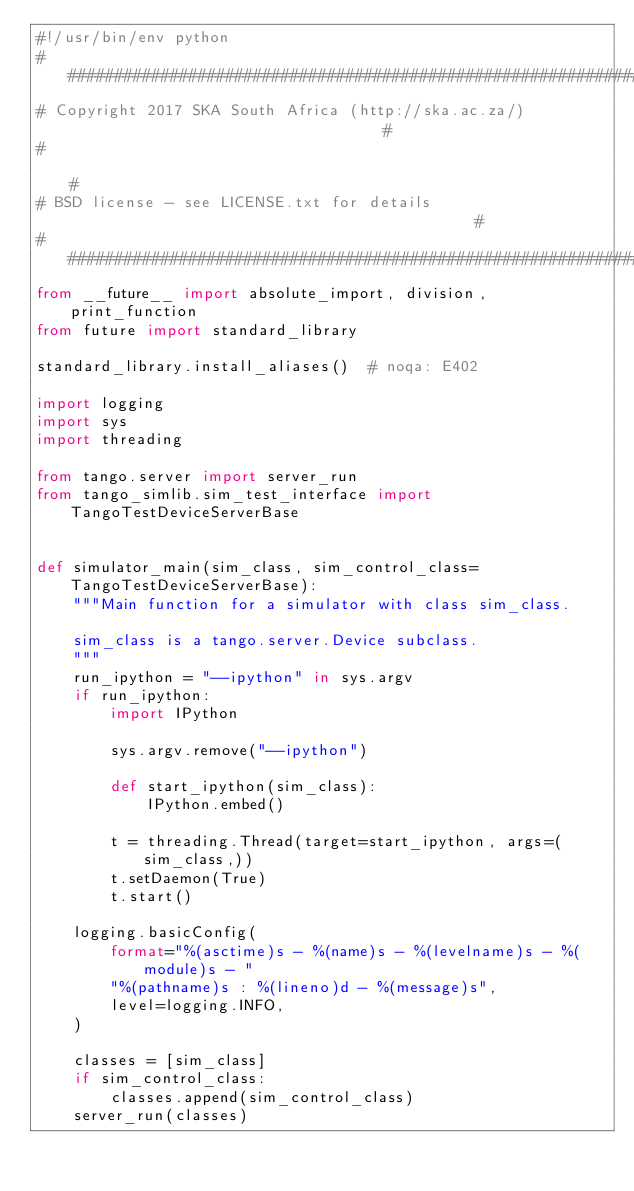Convert code to text. <code><loc_0><loc_0><loc_500><loc_500><_Python_>#!/usr/bin/env python
#########################################################################################
# Copyright 2017 SKA South Africa (http://ska.ac.za/)                                   #
#                                                                                       #
# BSD license - see LICENSE.txt for details                                             #
#########################################################################################
from __future__ import absolute_import, division, print_function
from future import standard_library

standard_library.install_aliases()  # noqa: E402

import logging
import sys
import threading

from tango.server import server_run
from tango_simlib.sim_test_interface import TangoTestDeviceServerBase


def simulator_main(sim_class, sim_control_class=TangoTestDeviceServerBase):
    """Main function for a simulator with class sim_class.

    sim_class is a tango.server.Device subclass.
    """
    run_ipython = "--ipython" in sys.argv
    if run_ipython:
        import IPython

        sys.argv.remove("--ipython")

        def start_ipython(sim_class):
            IPython.embed()

        t = threading.Thread(target=start_ipython, args=(sim_class,))
        t.setDaemon(True)
        t.start()

    logging.basicConfig(
        format="%(asctime)s - %(name)s - %(levelname)s - %(module)s - "
        "%(pathname)s : %(lineno)d - %(message)s",
        level=logging.INFO,
    )

    classes = [sim_class]
    if sim_control_class:
        classes.append(sim_control_class)
    server_run(classes)
</code> 